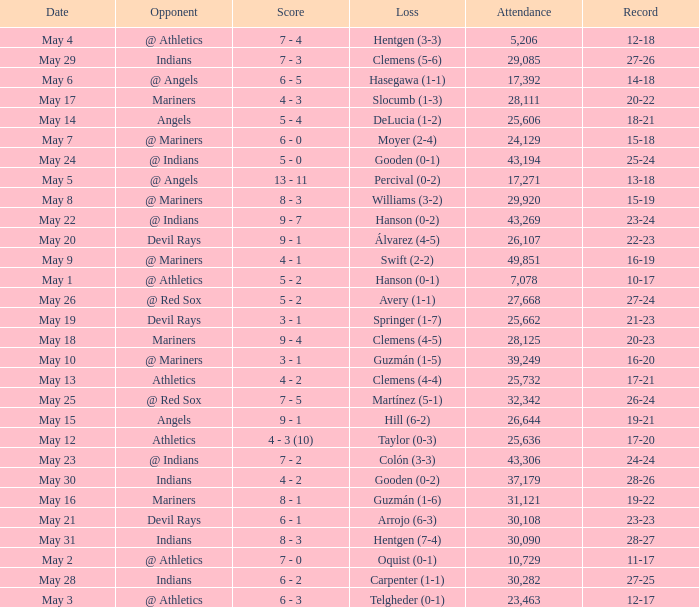When was the record 27-25? May 28. 